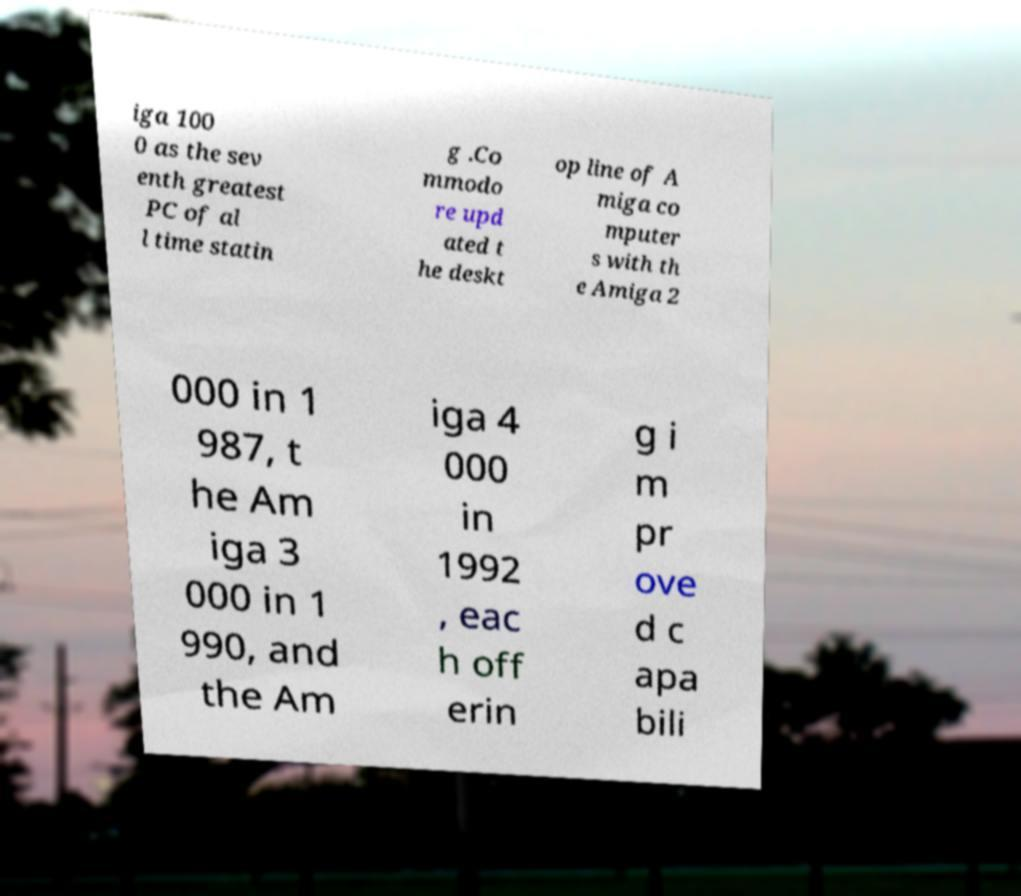Please read and relay the text visible in this image. What does it say? iga 100 0 as the sev enth greatest PC of al l time statin g .Co mmodo re upd ated t he deskt op line of A miga co mputer s with th e Amiga 2 000 in 1 987, t he Am iga 3 000 in 1 990, and the Am iga 4 000 in 1992 , eac h off erin g i m pr ove d c apa bili 